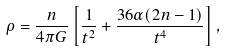Convert formula to latex. <formula><loc_0><loc_0><loc_500><loc_500>\rho = \frac { n } { 4 \pi G } \left [ \frac { 1 } { t ^ { 2 } } + \frac { 3 6 \alpha ( 2 n - 1 ) } { t ^ { 4 } } \right ] ,</formula> 